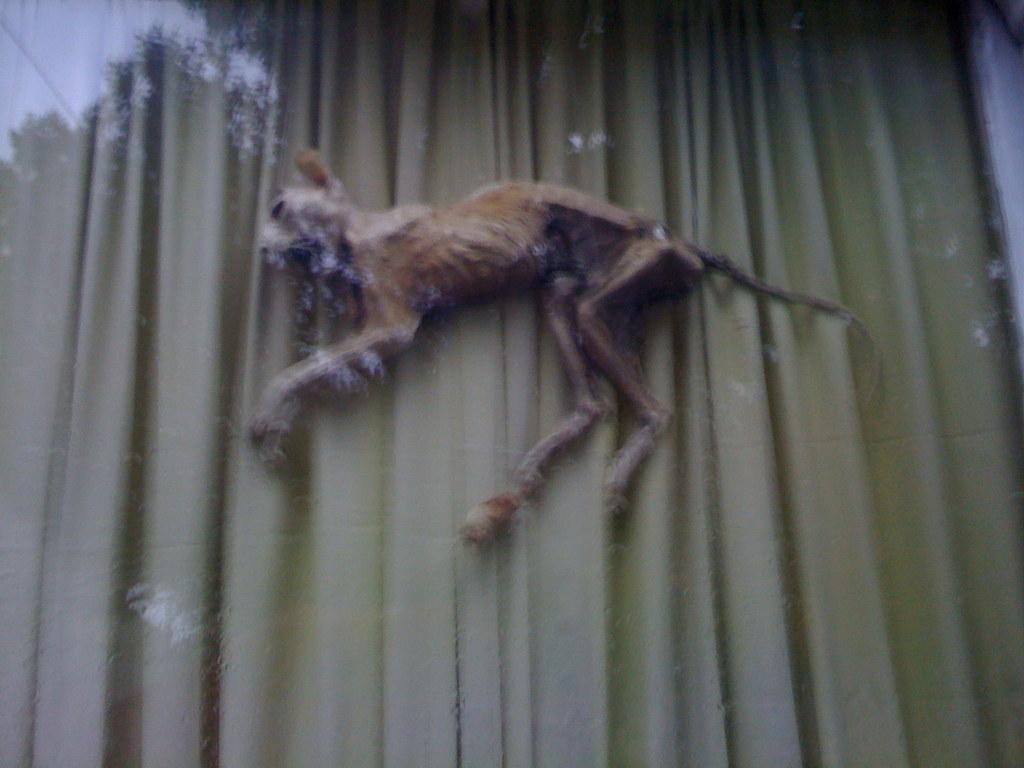Could you give a brief overview of what you see in this image? In this image we can see an animal and curtain in the background. 